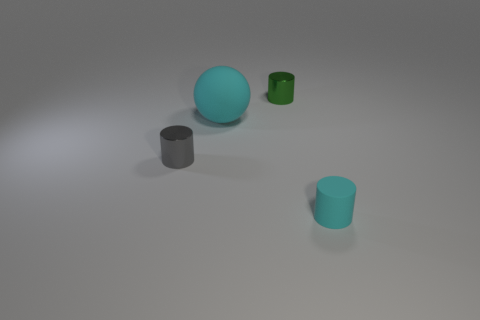Subtract all small matte cylinders. How many cylinders are left? 2 Add 1 tiny yellow cylinders. How many objects exist? 5 Subtract all gray cylinders. How many cylinders are left? 2 Subtract all cylinders. How many objects are left? 1 Add 1 cyan rubber objects. How many cyan rubber objects exist? 3 Subtract 0 purple balls. How many objects are left? 4 Subtract all purple cylinders. Subtract all green spheres. How many cylinders are left? 3 Subtract all tiny blue matte cylinders. Subtract all big matte spheres. How many objects are left? 3 Add 3 shiny cylinders. How many shiny cylinders are left? 5 